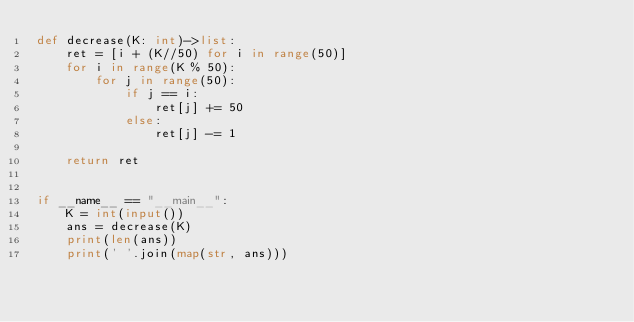Convert code to text. <code><loc_0><loc_0><loc_500><loc_500><_Python_>def decrease(K: int)->list:
    ret = [i + (K//50) for i in range(50)]
    for i in range(K % 50):
        for j in range(50):
            if j == i:
                ret[j] += 50
            else:
                ret[j] -= 1

    return ret


if __name__ == "__main__":
    K = int(input())
    ans = decrease(K)
    print(len(ans))
    print(' '.join(map(str, ans)))
</code> 